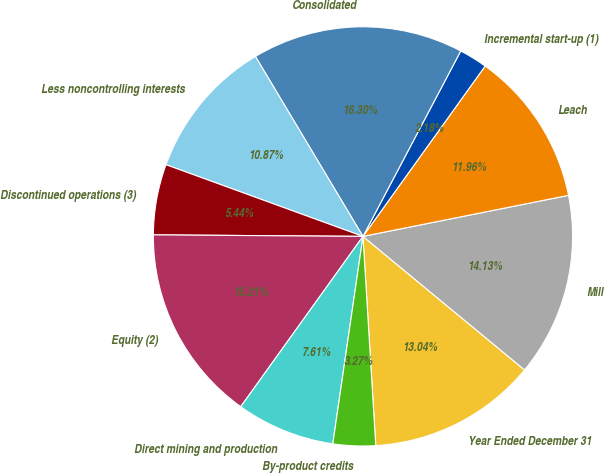<chart> <loc_0><loc_0><loc_500><loc_500><pie_chart><fcel>Year Ended December 31<fcel>Mill<fcel>Leach<fcel>Incremental start-up (1)<fcel>Consolidated<fcel>Less noncontrolling interests<fcel>Discontinued operations (3)<fcel>Equity (2)<fcel>Direct mining and production<fcel>By-product credits<nl><fcel>13.04%<fcel>14.13%<fcel>11.96%<fcel>2.18%<fcel>16.3%<fcel>10.87%<fcel>5.44%<fcel>15.21%<fcel>7.61%<fcel>3.27%<nl></chart> 